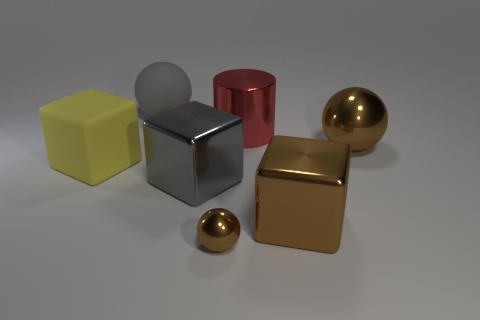How many other things are the same size as the gray block?
Your response must be concise. 5. How many things are large metal objects that are in front of the gray block or large things that are behind the yellow thing?
Give a very brief answer. 4. There is a big gray object that is the same shape as the small metal object; what is its material?
Your answer should be compact. Rubber. How many objects are large cubes that are on the right side of the large cylinder or big gray shiny cylinders?
Your answer should be compact. 1. The tiny brown thing that is the same material as the large cylinder is what shape?
Offer a very short reply. Sphere. What number of yellow rubber objects have the same shape as the big gray metallic thing?
Provide a succinct answer. 1. What is the yellow block made of?
Provide a succinct answer. Rubber. Is the color of the tiny shiny object the same as the block that is in front of the big gray metal object?
Your answer should be very brief. Yes. How many blocks are large gray shiny objects or brown metallic things?
Your answer should be compact. 2. There is a large metal object on the left side of the small ball; what color is it?
Provide a succinct answer. Gray. 